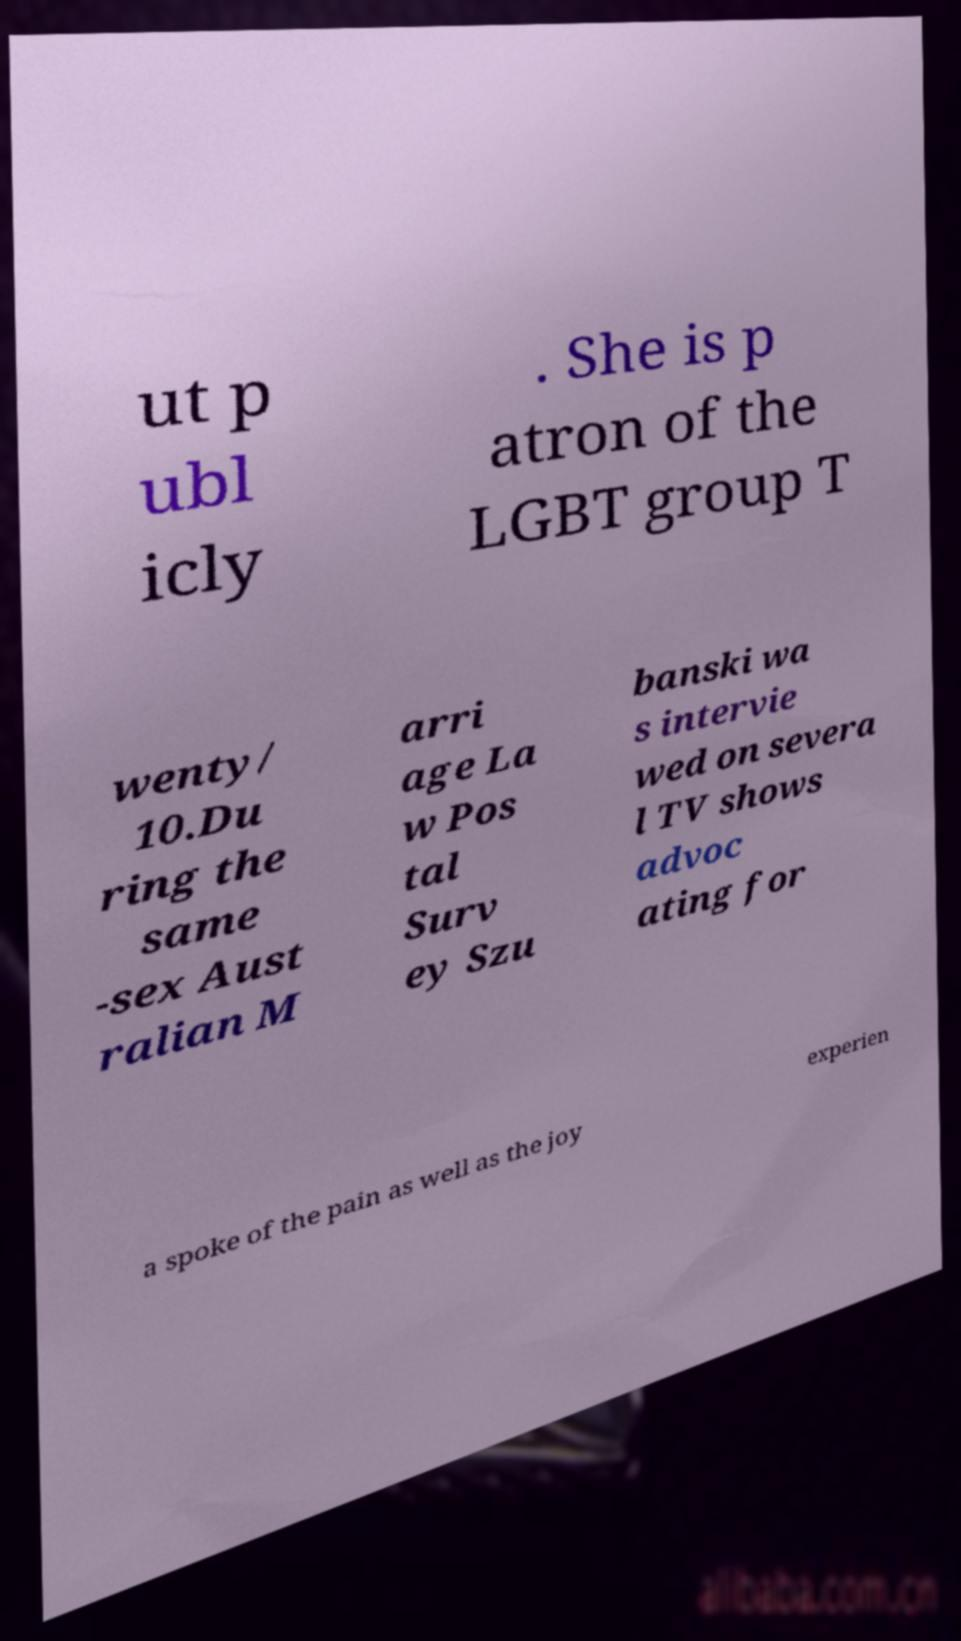What messages or text are displayed in this image? I need them in a readable, typed format. ut p ubl icly . She is p atron of the LGBT group T wenty/ 10.Du ring the same -sex Aust ralian M arri age La w Pos tal Surv ey Szu banski wa s intervie wed on severa l TV shows advoc ating for a spoke of the pain as well as the joy experien 